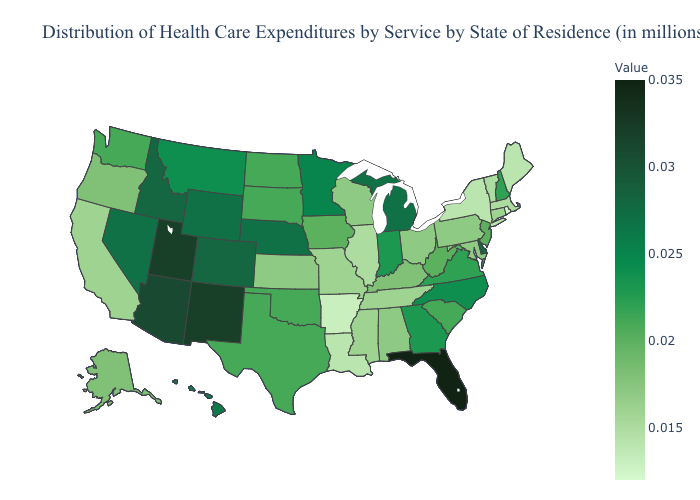Does South Carolina have the highest value in the South?
Short answer required. No. Which states have the highest value in the USA?
Quick response, please. Florida. Is the legend a continuous bar?
Keep it brief. Yes. 